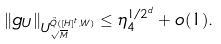Convert formula to latex. <formula><loc_0><loc_0><loc_500><loc_500>\| g _ { U } \| _ { U ^ { \vec { Q } ( [ H ] ^ { t } , W ) } _ { \sqrt { M } } } \leq \eta _ { 4 } ^ { 1 / 2 ^ { d } } + o ( 1 ) .</formula> 